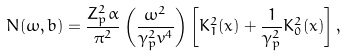<formula> <loc_0><loc_0><loc_500><loc_500>N ( \omega , b ) = \frac { Z _ { p } ^ { 2 } \alpha } { \pi ^ { 2 } } \left ( \frac { \omega ^ { 2 } } { \gamma _ { p } ^ { 2 } v ^ { 4 } } \right ) \left [ K _ { 1 } ^ { 2 } ( x ) + \frac { 1 } { \gamma _ { p } ^ { 2 } } K _ { 0 } ^ { 2 } ( x ) \right ] ,</formula> 